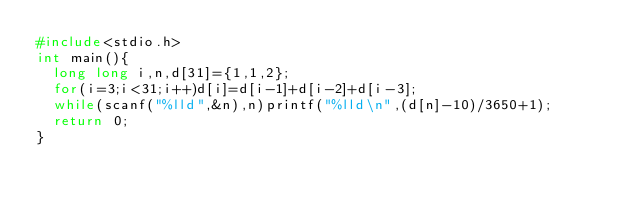Convert code to text. <code><loc_0><loc_0><loc_500><loc_500><_C_>#include<stdio.h>
int main(){
  long long i,n,d[31]={1,1,2};
  for(i=3;i<31;i++)d[i]=d[i-1]+d[i-2]+d[i-3];
  while(scanf("%lld",&n),n)printf("%lld\n",(d[n]-10)/3650+1);
  return 0;
}</code> 